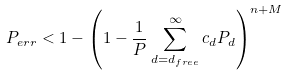<formula> <loc_0><loc_0><loc_500><loc_500>P _ { e r r } < 1 - \left ( 1 - \frac { 1 } { P } \sum _ { d = d _ { f r e e } } ^ { \infty } c _ { d } P _ { d } \right ) ^ { n + M }</formula> 